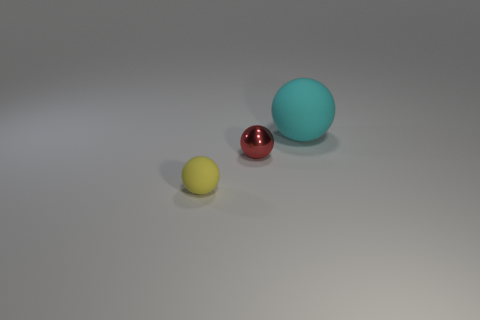There is a matte ball that is to the right of the metallic object; how big is it?
Keep it short and to the point. Large. What is the shape of the small object that is the same material as the large cyan ball?
Offer a terse response. Sphere. Are the small sphere in front of the small red thing and the red thing made of the same material?
Your answer should be very brief. No. What number of other objects are there of the same material as the cyan ball?
Keep it short and to the point. 1. What number of things are things right of the tiny red metallic thing or objects behind the yellow sphere?
Provide a succinct answer. 2. The red metal object that is the same size as the yellow thing is what shape?
Your response must be concise. Sphere. How many rubber things are either large yellow things or tiny spheres?
Give a very brief answer. 1. Are the tiny yellow ball in front of the tiny red ball and the small ball that is behind the yellow sphere made of the same material?
Give a very brief answer. No. What color is the object that is the same material as the big ball?
Provide a succinct answer. Yellow. Are there more objects in front of the big ball than tiny red metal balls that are to the right of the tiny metal sphere?
Offer a very short reply. Yes. 